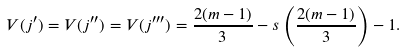Convert formula to latex. <formula><loc_0><loc_0><loc_500><loc_500>V ( j ^ { \prime } ) = V ( j ^ { \prime \prime } ) = V ( j ^ { \prime \prime \prime } ) = \frac { 2 ( m - 1 ) } { 3 } - s \left ( \frac { 2 ( m - 1 ) } { 3 } \right ) - 1 .</formula> 